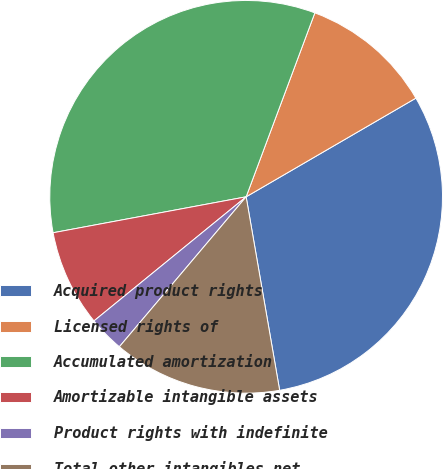Convert chart. <chart><loc_0><loc_0><loc_500><loc_500><pie_chart><fcel>Acquired product rights<fcel>Licensed rights of<fcel>Accumulated amortization<fcel>Amortizable intangible assets<fcel>Product rights with indefinite<fcel>Total other intangibles net<nl><fcel>30.65%<fcel>10.93%<fcel>33.62%<fcel>7.96%<fcel>2.94%<fcel>13.9%<nl></chart> 